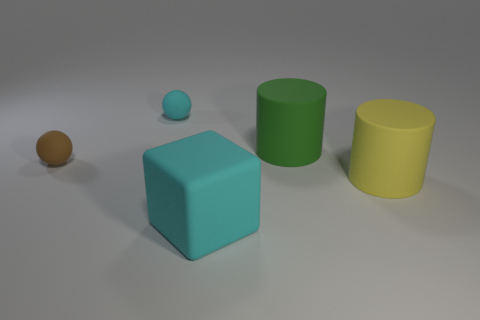How many balls have the same color as the large matte block?
Your answer should be very brief. 1. What number of things are rubber balls left of the cyan ball or rubber things that are to the right of the brown ball?
Your response must be concise. 5. Is the number of things greater than the number of tiny brown matte things?
Make the answer very short. Yes. The big thing left of the large green rubber cylinder is what color?
Provide a short and direct response. Cyan. Do the green thing and the yellow matte thing have the same shape?
Provide a succinct answer. Yes. There is a large rubber object that is left of the yellow rubber thing and in front of the green rubber cylinder; what is its color?
Provide a short and direct response. Cyan. Does the cyan rubber object behind the large matte block have the same size as the rubber cylinder that is right of the big green matte cylinder?
Your answer should be compact. No. How many things are small rubber balls that are on the right side of the small brown ball or tiny spheres?
Ensure brevity in your answer.  2. Is the yellow thing the same size as the rubber cube?
Your answer should be very brief. Yes. What number of balls are small green metal objects or cyan rubber objects?
Provide a succinct answer. 1. 